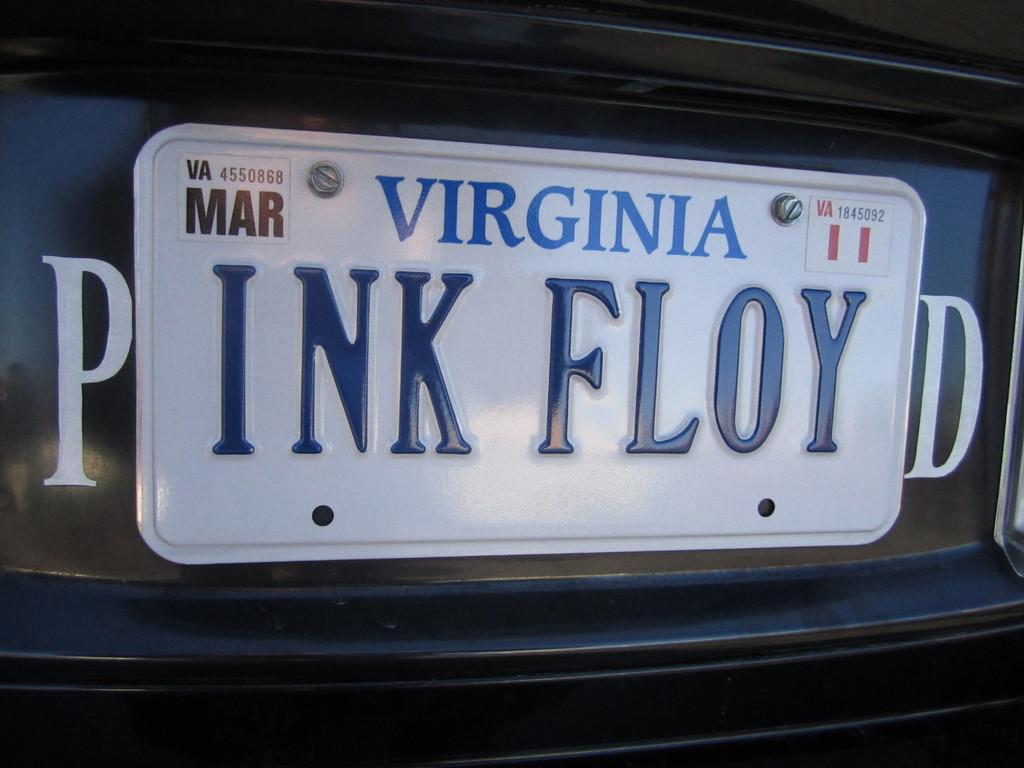Provide a one-sentence caption for the provided image. A Virginia vanity license plate reads "INK FLOY" and is positioned between a P and a D so it reads "PINK FLOYD.". 